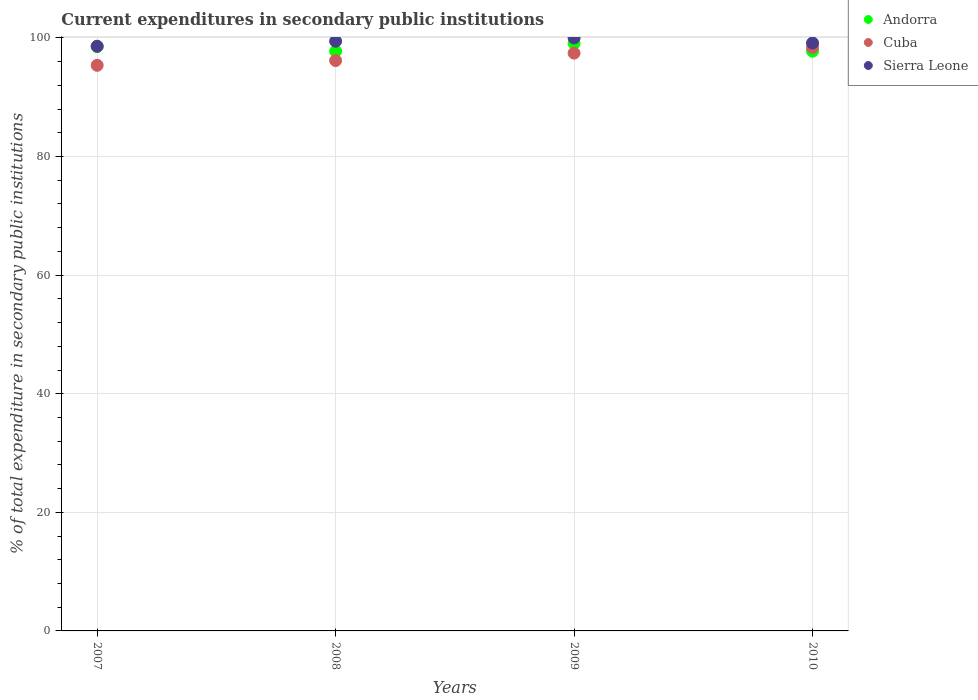What is the current expenditures in secondary public institutions in Sierra Leone in 2010?
Keep it short and to the point. 99.15. Across all years, what is the maximum current expenditures in secondary public institutions in Andorra?
Make the answer very short. 99.09. Across all years, what is the minimum current expenditures in secondary public institutions in Andorra?
Your answer should be compact. 97.76. What is the total current expenditures in secondary public institutions in Sierra Leone in the graph?
Offer a very short reply. 397.19. What is the difference between the current expenditures in secondary public institutions in Cuba in 2008 and that in 2009?
Ensure brevity in your answer.  -1.25. What is the difference between the current expenditures in secondary public institutions in Cuba in 2009 and the current expenditures in secondary public institutions in Sierra Leone in 2008?
Your answer should be very brief. -2.01. What is the average current expenditures in secondary public institutions in Cuba per year?
Make the answer very short. 96.85. In the year 2008, what is the difference between the current expenditures in secondary public institutions in Cuba and current expenditures in secondary public institutions in Sierra Leone?
Provide a short and direct response. -3.26. What is the ratio of the current expenditures in secondary public institutions in Cuba in 2007 to that in 2010?
Your answer should be very brief. 0.97. Is the difference between the current expenditures in secondary public institutions in Cuba in 2007 and 2009 greater than the difference between the current expenditures in secondary public institutions in Sierra Leone in 2007 and 2009?
Keep it short and to the point. No. What is the difference between the highest and the second highest current expenditures in secondary public institutions in Cuba?
Give a very brief answer. 0.96. What is the difference between the highest and the lowest current expenditures in secondary public institutions in Andorra?
Your response must be concise. 1.33. In how many years, is the current expenditures in secondary public institutions in Sierra Leone greater than the average current expenditures in secondary public institutions in Sierra Leone taken over all years?
Your answer should be compact. 2. Is the current expenditures in secondary public institutions in Andorra strictly greater than the current expenditures in secondary public institutions in Sierra Leone over the years?
Offer a very short reply. No. How many years are there in the graph?
Your response must be concise. 4. Are the values on the major ticks of Y-axis written in scientific E-notation?
Ensure brevity in your answer.  No. Does the graph contain any zero values?
Offer a very short reply. No. Where does the legend appear in the graph?
Provide a succinct answer. Top right. How many legend labels are there?
Provide a succinct answer. 3. How are the legend labels stacked?
Ensure brevity in your answer.  Vertical. What is the title of the graph?
Make the answer very short. Current expenditures in secondary public institutions. Does "San Marino" appear as one of the legend labels in the graph?
Keep it short and to the point. No. What is the label or title of the Y-axis?
Offer a very short reply. % of total expenditure in secondary public institutions. What is the % of total expenditure in secondary public institutions in Andorra in 2007?
Offer a terse response. 98.56. What is the % of total expenditure in secondary public institutions in Cuba in 2007?
Provide a succinct answer. 95.38. What is the % of total expenditure in secondary public institutions in Sierra Leone in 2007?
Offer a very short reply. 98.6. What is the % of total expenditure in secondary public institutions in Andorra in 2008?
Make the answer very short. 97.76. What is the % of total expenditure in secondary public institutions in Cuba in 2008?
Your answer should be compact. 96.19. What is the % of total expenditure in secondary public institutions of Sierra Leone in 2008?
Your answer should be very brief. 99.45. What is the % of total expenditure in secondary public institutions in Andorra in 2009?
Your answer should be compact. 99.09. What is the % of total expenditure in secondary public institutions in Cuba in 2009?
Your response must be concise. 97.44. What is the % of total expenditure in secondary public institutions in Andorra in 2010?
Offer a terse response. 97.78. What is the % of total expenditure in secondary public institutions of Cuba in 2010?
Make the answer very short. 98.4. What is the % of total expenditure in secondary public institutions in Sierra Leone in 2010?
Provide a succinct answer. 99.15. Across all years, what is the maximum % of total expenditure in secondary public institutions of Andorra?
Offer a very short reply. 99.09. Across all years, what is the maximum % of total expenditure in secondary public institutions in Cuba?
Your response must be concise. 98.4. Across all years, what is the maximum % of total expenditure in secondary public institutions in Sierra Leone?
Your response must be concise. 100. Across all years, what is the minimum % of total expenditure in secondary public institutions of Andorra?
Your answer should be very brief. 97.76. Across all years, what is the minimum % of total expenditure in secondary public institutions of Cuba?
Your answer should be very brief. 95.38. Across all years, what is the minimum % of total expenditure in secondary public institutions of Sierra Leone?
Ensure brevity in your answer.  98.6. What is the total % of total expenditure in secondary public institutions in Andorra in the graph?
Give a very brief answer. 393.18. What is the total % of total expenditure in secondary public institutions in Cuba in the graph?
Offer a very short reply. 387.41. What is the total % of total expenditure in secondary public institutions of Sierra Leone in the graph?
Offer a very short reply. 397.19. What is the difference between the % of total expenditure in secondary public institutions in Andorra in 2007 and that in 2008?
Make the answer very short. 0.8. What is the difference between the % of total expenditure in secondary public institutions of Cuba in 2007 and that in 2008?
Ensure brevity in your answer.  -0.8. What is the difference between the % of total expenditure in secondary public institutions in Sierra Leone in 2007 and that in 2008?
Offer a terse response. -0.85. What is the difference between the % of total expenditure in secondary public institutions of Andorra in 2007 and that in 2009?
Your answer should be very brief. -0.53. What is the difference between the % of total expenditure in secondary public institutions in Cuba in 2007 and that in 2009?
Your response must be concise. -2.06. What is the difference between the % of total expenditure in secondary public institutions in Sierra Leone in 2007 and that in 2009?
Ensure brevity in your answer.  -1.4. What is the difference between the % of total expenditure in secondary public institutions in Andorra in 2007 and that in 2010?
Ensure brevity in your answer.  0.78. What is the difference between the % of total expenditure in secondary public institutions of Cuba in 2007 and that in 2010?
Ensure brevity in your answer.  -3.01. What is the difference between the % of total expenditure in secondary public institutions of Sierra Leone in 2007 and that in 2010?
Your answer should be compact. -0.55. What is the difference between the % of total expenditure in secondary public institutions in Andorra in 2008 and that in 2009?
Give a very brief answer. -1.33. What is the difference between the % of total expenditure in secondary public institutions in Cuba in 2008 and that in 2009?
Your answer should be very brief. -1.25. What is the difference between the % of total expenditure in secondary public institutions of Sierra Leone in 2008 and that in 2009?
Give a very brief answer. -0.55. What is the difference between the % of total expenditure in secondary public institutions in Andorra in 2008 and that in 2010?
Your response must be concise. -0.02. What is the difference between the % of total expenditure in secondary public institutions of Cuba in 2008 and that in 2010?
Offer a very short reply. -2.21. What is the difference between the % of total expenditure in secondary public institutions in Sierra Leone in 2008 and that in 2010?
Keep it short and to the point. 0.3. What is the difference between the % of total expenditure in secondary public institutions in Andorra in 2009 and that in 2010?
Offer a terse response. 1.31. What is the difference between the % of total expenditure in secondary public institutions in Cuba in 2009 and that in 2010?
Keep it short and to the point. -0.96. What is the difference between the % of total expenditure in secondary public institutions in Sierra Leone in 2009 and that in 2010?
Give a very brief answer. 0.85. What is the difference between the % of total expenditure in secondary public institutions in Andorra in 2007 and the % of total expenditure in secondary public institutions in Cuba in 2008?
Give a very brief answer. 2.37. What is the difference between the % of total expenditure in secondary public institutions in Andorra in 2007 and the % of total expenditure in secondary public institutions in Sierra Leone in 2008?
Provide a succinct answer. -0.89. What is the difference between the % of total expenditure in secondary public institutions of Cuba in 2007 and the % of total expenditure in secondary public institutions of Sierra Leone in 2008?
Make the answer very short. -4.06. What is the difference between the % of total expenditure in secondary public institutions of Andorra in 2007 and the % of total expenditure in secondary public institutions of Cuba in 2009?
Offer a very short reply. 1.12. What is the difference between the % of total expenditure in secondary public institutions in Andorra in 2007 and the % of total expenditure in secondary public institutions in Sierra Leone in 2009?
Provide a short and direct response. -1.44. What is the difference between the % of total expenditure in secondary public institutions of Cuba in 2007 and the % of total expenditure in secondary public institutions of Sierra Leone in 2009?
Make the answer very short. -4.62. What is the difference between the % of total expenditure in secondary public institutions of Andorra in 2007 and the % of total expenditure in secondary public institutions of Cuba in 2010?
Offer a very short reply. 0.16. What is the difference between the % of total expenditure in secondary public institutions in Andorra in 2007 and the % of total expenditure in secondary public institutions in Sierra Leone in 2010?
Your answer should be compact. -0.59. What is the difference between the % of total expenditure in secondary public institutions in Cuba in 2007 and the % of total expenditure in secondary public institutions in Sierra Leone in 2010?
Ensure brevity in your answer.  -3.76. What is the difference between the % of total expenditure in secondary public institutions of Andorra in 2008 and the % of total expenditure in secondary public institutions of Cuba in 2009?
Provide a succinct answer. 0.32. What is the difference between the % of total expenditure in secondary public institutions of Andorra in 2008 and the % of total expenditure in secondary public institutions of Sierra Leone in 2009?
Your response must be concise. -2.24. What is the difference between the % of total expenditure in secondary public institutions in Cuba in 2008 and the % of total expenditure in secondary public institutions in Sierra Leone in 2009?
Your answer should be compact. -3.81. What is the difference between the % of total expenditure in secondary public institutions of Andorra in 2008 and the % of total expenditure in secondary public institutions of Cuba in 2010?
Provide a short and direct response. -0.64. What is the difference between the % of total expenditure in secondary public institutions of Andorra in 2008 and the % of total expenditure in secondary public institutions of Sierra Leone in 2010?
Your response must be concise. -1.39. What is the difference between the % of total expenditure in secondary public institutions in Cuba in 2008 and the % of total expenditure in secondary public institutions in Sierra Leone in 2010?
Ensure brevity in your answer.  -2.96. What is the difference between the % of total expenditure in secondary public institutions of Andorra in 2009 and the % of total expenditure in secondary public institutions of Cuba in 2010?
Ensure brevity in your answer.  0.69. What is the difference between the % of total expenditure in secondary public institutions of Andorra in 2009 and the % of total expenditure in secondary public institutions of Sierra Leone in 2010?
Give a very brief answer. -0.06. What is the difference between the % of total expenditure in secondary public institutions of Cuba in 2009 and the % of total expenditure in secondary public institutions of Sierra Leone in 2010?
Your response must be concise. -1.71. What is the average % of total expenditure in secondary public institutions in Andorra per year?
Your answer should be very brief. 98.29. What is the average % of total expenditure in secondary public institutions of Cuba per year?
Ensure brevity in your answer.  96.85. What is the average % of total expenditure in secondary public institutions of Sierra Leone per year?
Offer a terse response. 99.3. In the year 2007, what is the difference between the % of total expenditure in secondary public institutions in Andorra and % of total expenditure in secondary public institutions in Cuba?
Ensure brevity in your answer.  3.17. In the year 2007, what is the difference between the % of total expenditure in secondary public institutions of Andorra and % of total expenditure in secondary public institutions of Sierra Leone?
Make the answer very short. -0.04. In the year 2007, what is the difference between the % of total expenditure in secondary public institutions of Cuba and % of total expenditure in secondary public institutions of Sierra Leone?
Keep it short and to the point. -3.21. In the year 2008, what is the difference between the % of total expenditure in secondary public institutions in Andorra and % of total expenditure in secondary public institutions in Cuba?
Provide a short and direct response. 1.57. In the year 2008, what is the difference between the % of total expenditure in secondary public institutions of Andorra and % of total expenditure in secondary public institutions of Sierra Leone?
Your response must be concise. -1.69. In the year 2008, what is the difference between the % of total expenditure in secondary public institutions in Cuba and % of total expenditure in secondary public institutions in Sierra Leone?
Provide a succinct answer. -3.26. In the year 2009, what is the difference between the % of total expenditure in secondary public institutions in Andorra and % of total expenditure in secondary public institutions in Cuba?
Give a very brief answer. 1.65. In the year 2009, what is the difference between the % of total expenditure in secondary public institutions of Andorra and % of total expenditure in secondary public institutions of Sierra Leone?
Offer a very short reply. -0.91. In the year 2009, what is the difference between the % of total expenditure in secondary public institutions of Cuba and % of total expenditure in secondary public institutions of Sierra Leone?
Offer a very short reply. -2.56. In the year 2010, what is the difference between the % of total expenditure in secondary public institutions in Andorra and % of total expenditure in secondary public institutions in Cuba?
Your answer should be very brief. -0.62. In the year 2010, what is the difference between the % of total expenditure in secondary public institutions in Andorra and % of total expenditure in secondary public institutions in Sierra Leone?
Give a very brief answer. -1.37. In the year 2010, what is the difference between the % of total expenditure in secondary public institutions in Cuba and % of total expenditure in secondary public institutions in Sierra Leone?
Ensure brevity in your answer.  -0.75. What is the ratio of the % of total expenditure in secondary public institutions of Andorra in 2007 to that in 2008?
Provide a short and direct response. 1.01. What is the ratio of the % of total expenditure in secondary public institutions in Sierra Leone in 2007 to that in 2008?
Make the answer very short. 0.99. What is the ratio of the % of total expenditure in secondary public institutions of Cuba in 2007 to that in 2009?
Ensure brevity in your answer.  0.98. What is the ratio of the % of total expenditure in secondary public institutions of Sierra Leone in 2007 to that in 2009?
Your answer should be very brief. 0.99. What is the ratio of the % of total expenditure in secondary public institutions in Cuba in 2007 to that in 2010?
Offer a terse response. 0.97. What is the ratio of the % of total expenditure in secondary public institutions of Sierra Leone in 2007 to that in 2010?
Your answer should be compact. 0.99. What is the ratio of the % of total expenditure in secondary public institutions of Andorra in 2008 to that in 2009?
Keep it short and to the point. 0.99. What is the ratio of the % of total expenditure in secondary public institutions of Cuba in 2008 to that in 2009?
Give a very brief answer. 0.99. What is the ratio of the % of total expenditure in secondary public institutions of Cuba in 2008 to that in 2010?
Keep it short and to the point. 0.98. What is the ratio of the % of total expenditure in secondary public institutions of Sierra Leone in 2008 to that in 2010?
Offer a very short reply. 1. What is the ratio of the % of total expenditure in secondary public institutions of Andorra in 2009 to that in 2010?
Provide a short and direct response. 1.01. What is the ratio of the % of total expenditure in secondary public institutions of Cuba in 2009 to that in 2010?
Your answer should be very brief. 0.99. What is the ratio of the % of total expenditure in secondary public institutions of Sierra Leone in 2009 to that in 2010?
Keep it short and to the point. 1.01. What is the difference between the highest and the second highest % of total expenditure in secondary public institutions in Andorra?
Your answer should be very brief. 0.53. What is the difference between the highest and the second highest % of total expenditure in secondary public institutions in Cuba?
Ensure brevity in your answer.  0.96. What is the difference between the highest and the second highest % of total expenditure in secondary public institutions of Sierra Leone?
Your response must be concise. 0.55. What is the difference between the highest and the lowest % of total expenditure in secondary public institutions in Andorra?
Provide a succinct answer. 1.33. What is the difference between the highest and the lowest % of total expenditure in secondary public institutions of Cuba?
Ensure brevity in your answer.  3.01. What is the difference between the highest and the lowest % of total expenditure in secondary public institutions in Sierra Leone?
Your response must be concise. 1.4. 